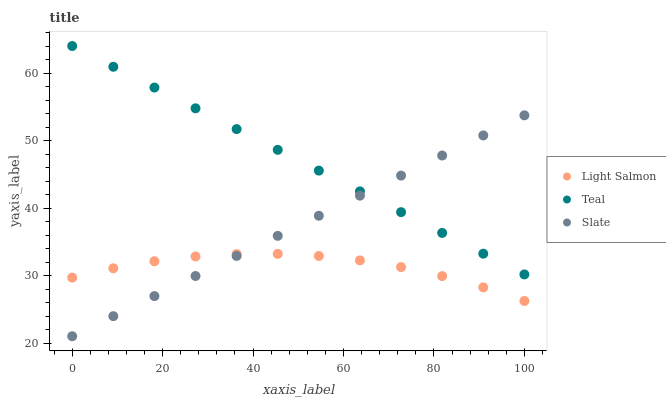Does Light Salmon have the minimum area under the curve?
Answer yes or no. Yes. Does Teal have the maximum area under the curve?
Answer yes or no. Yes. Does Slate have the minimum area under the curve?
Answer yes or no. No. Does Slate have the maximum area under the curve?
Answer yes or no. No. Is Slate the smoothest?
Answer yes or no. Yes. Is Light Salmon the roughest?
Answer yes or no. Yes. Is Teal the smoothest?
Answer yes or no. No. Is Teal the roughest?
Answer yes or no. No. Does Slate have the lowest value?
Answer yes or no. Yes. Does Teal have the lowest value?
Answer yes or no. No. Does Teal have the highest value?
Answer yes or no. Yes. Does Slate have the highest value?
Answer yes or no. No. Is Light Salmon less than Teal?
Answer yes or no. Yes. Is Teal greater than Light Salmon?
Answer yes or no. Yes. Does Teal intersect Slate?
Answer yes or no. Yes. Is Teal less than Slate?
Answer yes or no. No. Is Teal greater than Slate?
Answer yes or no. No. Does Light Salmon intersect Teal?
Answer yes or no. No. 